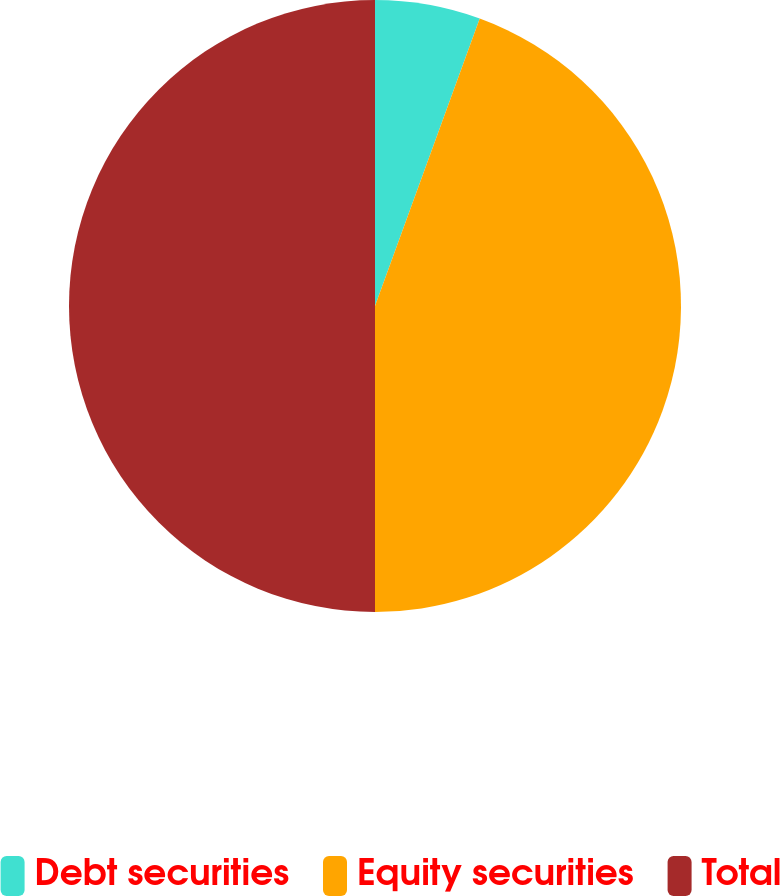Convert chart. <chart><loc_0><loc_0><loc_500><loc_500><pie_chart><fcel>Debt securities<fcel>Equity securities<fcel>Total<nl><fcel>5.56%<fcel>44.44%<fcel>50.0%<nl></chart> 